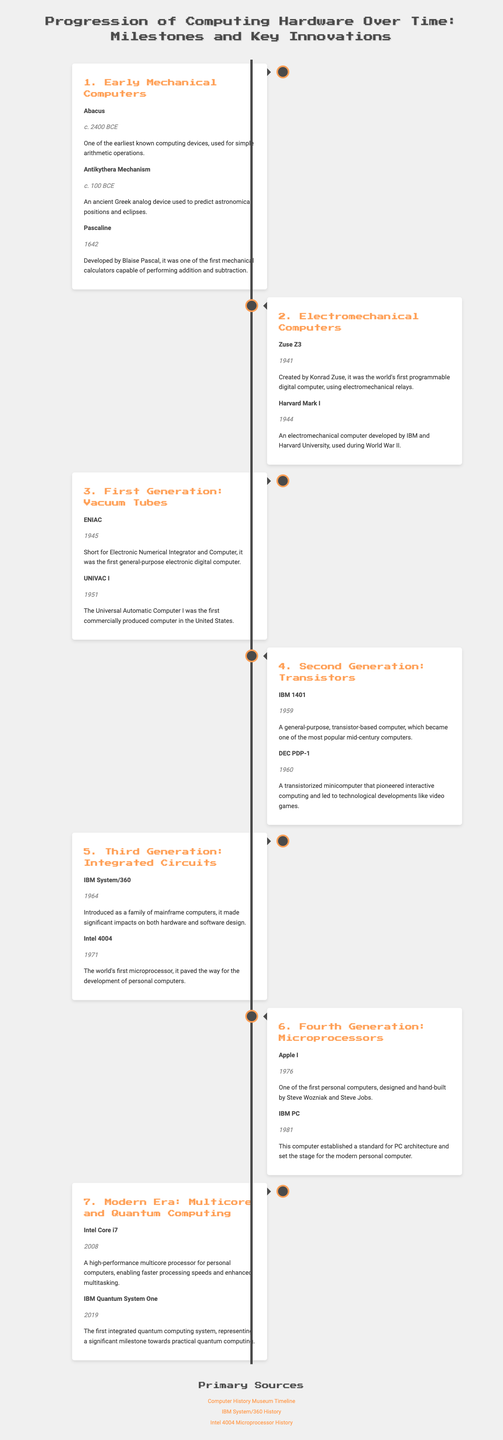what is the year of the invention of the Abacus? The year of the invention of the Abacus is indicated as c. 2400 BCE in the document.
Answer: c. 2400 BCE who developed the UNIVAC I? The UNIVAC I was the first commercially produced computer in the United States, but the document does not specify the developer.
Answer: Not specified what computing device was created by Blaise Pascal? Blaise Pascal created the Pascaline, which is mentioned in the document as a mechanical calculator.
Answer: Pascaline which computer is known as the first programmable digital computer? The document states that the Zuse Z3 is known as the world's first programmable digital computer.
Answer: Zuse Z3 what significant breakthrough is associated with the Intel 4004? The document mentions that the Intel 4004 is known as the world's first microprocessor.
Answer: world's first microprocessor which computer established a standard for PC architecture? The IBM PC is highlighted in the document as establishing a standard for PC architecture.
Answer: IBM PC in which year was the IBM Quantum System One introduced? According to the document, the IBM Quantum System One was introduced in 2019.
Answer: 2019 what important milestone did the IBM System/360 represent? The document indicates that the IBM System/360 made significant impacts on both hardware and software design.
Answer: significant impacts on both hardware and software design which two devices are mentioned in the modern era section of the document? The document lists Intel Core i7 and IBM Quantum System One as notable devices in the modern era.
Answer: Intel Core i7 and IBM Quantum System One 